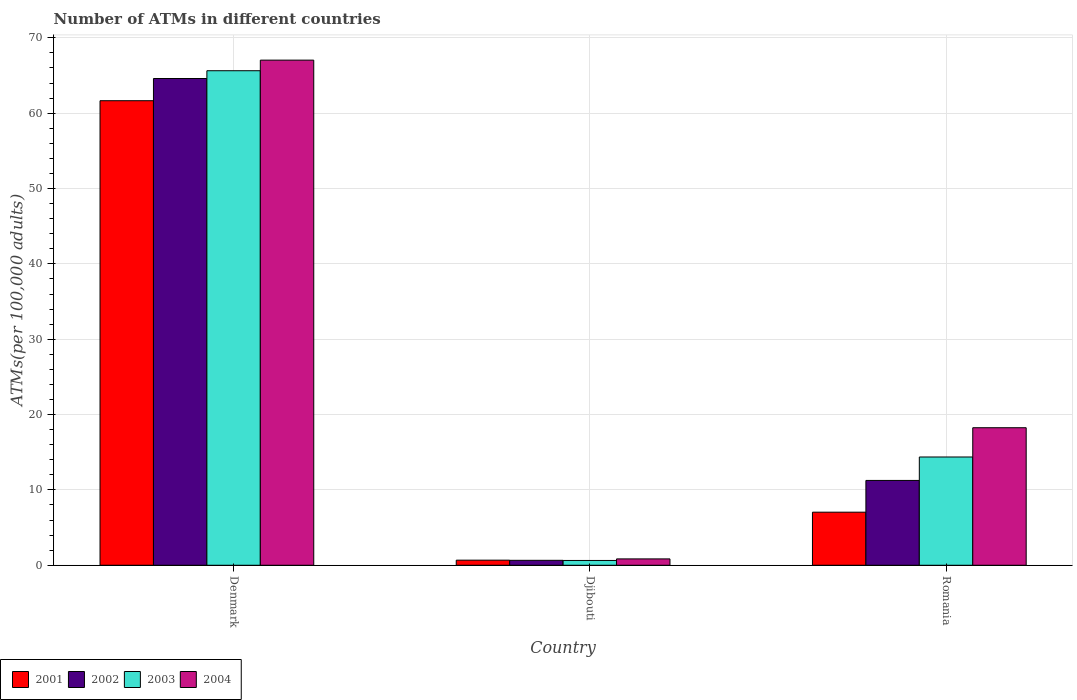How many different coloured bars are there?
Offer a very short reply. 4. How many bars are there on the 1st tick from the left?
Ensure brevity in your answer.  4. What is the label of the 3rd group of bars from the left?
Keep it short and to the point. Romania. In how many cases, is the number of bars for a given country not equal to the number of legend labels?
Provide a succinct answer. 0. What is the number of ATMs in 2004 in Djibouti?
Your response must be concise. 0.84. Across all countries, what is the maximum number of ATMs in 2002?
Keep it short and to the point. 64.61. Across all countries, what is the minimum number of ATMs in 2002?
Your answer should be compact. 0.66. In which country was the number of ATMs in 2001 minimum?
Your answer should be very brief. Djibouti. What is the total number of ATMs in 2003 in the graph?
Offer a terse response. 80.65. What is the difference between the number of ATMs in 2003 in Djibouti and that in Romania?
Offer a very short reply. -13.73. What is the difference between the number of ATMs in 2002 in Denmark and the number of ATMs in 2001 in Romania?
Make the answer very short. 57.56. What is the average number of ATMs in 2002 per country?
Your answer should be compact. 25.51. What is the difference between the number of ATMs of/in 2002 and number of ATMs of/in 2003 in Denmark?
Your answer should be compact. -1.03. What is the ratio of the number of ATMs in 2004 in Denmark to that in Djibouti?
Your response must be concise. 79.46. Is the number of ATMs in 2003 in Denmark less than that in Romania?
Give a very brief answer. No. Is the difference between the number of ATMs in 2002 in Djibouti and Romania greater than the difference between the number of ATMs in 2003 in Djibouti and Romania?
Offer a very short reply. Yes. What is the difference between the highest and the second highest number of ATMs in 2004?
Your answer should be very brief. -17.41. What is the difference between the highest and the lowest number of ATMs in 2004?
Keep it short and to the point. 66.2. Is the sum of the number of ATMs in 2002 in Denmark and Romania greater than the maximum number of ATMs in 2004 across all countries?
Keep it short and to the point. Yes. What does the 2nd bar from the left in Djibouti represents?
Ensure brevity in your answer.  2002. What does the 2nd bar from the right in Djibouti represents?
Your answer should be very brief. 2003. What is the difference between two consecutive major ticks on the Y-axis?
Give a very brief answer. 10. Are the values on the major ticks of Y-axis written in scientific E-notation?
Offer a very short reply. No. Does the graph contain any zero values?
Keep it short and to the point. No. Where does the legend appear in the graph?
Ensure brevity in your answer.  Bottom left. How many legend labels are there?
Provide a short and direct response. 4. What is the title of the graph?
Offer a terse response. Number of ATMs in different countries. What is the label or title of the Y-axis?
Offer a very short reply. ATMs(per 100,0 adults). What is the ATMs(per 100,000 adults) in 2001 in Denmark?
Provide a short and direct response. 61.66. What is the ATMs(per 100,000 adults) in 2002 in Denmark?
Give a very brief answer. 64.61. What is the ATMs(per 100,000 adults) in 2003 in Denmark?
Provide a succinct answer. 65.64. What is the ATMs(per 100,000 adults) in 2004 in Denmark?
Offer a very short reply. 67.04. What is the ATMs(per 100,000 adults) in 2001 in Djibouti?
Your response must be concise. 0.68. What is the ATMs(per 100,000 adults) in 2002 in Djibouti?
Offer a terse response. 0.66. What is the ATMs(per 100,000 adults) in 2003 in Djibouti?
Give a very brief answer. 0.64. What is the ATMs(per 100,000 adults) of 2004 in Djibouti?
Your answer should be compact. 0.84. What is the ATMs(per 100,000 adults) of 2001 in Romania?
Your answer should be very brief. 7.04. What is the ATMs(per 100,000 adults) of 2002 in Romania?
Your response must be concise. 11.26. What is the ATMs(per 100,000 adults) in 2003 in Romania?
Keep it short and to the point. 14.37. What is the ATMs(per 100,000 adults) in 2004 in Romania?
Ensure brevity in your answer.  18.26. Across all countries, what is the maximum ATMs(per 100,000 adults) in 2001?
Your answer should be very brief. 61.66. Across all countries, what is the maximum ATMs(per 100,000 adults) in 2002?
Ensure brevity in your answer.  64.61. Across all countries, what is the maximum ATMs(per 100,000 adults) of 2003?
Provide a short and direct response. 65.64. Across all countries, what is the maximum ATMs(per 100,000 adults) in 2004?
Your answer should be compact. 67.04. Across all countries, what is the minimum ATMs(per 100,000 adults) in 2001?
Offer a terse response. 0.68. Across all countries, what is the minimum ATMs(per 100,000 adults) of 2002?
Offer a terse response. 0.66. Across all countries, what is the minimum ATMs(per 100,000 adults) in 2003?
Ensure brevity in your answer.  0.64. Across all countries, what is the minimum ATMs(per 100,000 adults) of 2004?
Offer a very short reply. 0.84. What is the total ATMs(per 100,000 adults) in 2001 in the graph?
Make the answer very short. 69.38. What is the total ATMs(per 100,000 adults) in 2002 in the graph?
Ensure brevity in your answer.  76.52. What is the total ATMs(per 100,000 adults) in 2003 in the graph?
Your response must be concise. 80.65. What is the total ATMs(per 100,000 adults) of 2004 in the graph?
Keep it short and to the point. 86.14. What is the difference between the ATMs(per 100,000 adults) in 2001 in Denmark and that in Djibouti?
Offer a very short reply. 60.98. What is the difference between the ATMs(per 100,000 adults) of 2002 in Denmark and that in Djibouti?
Your response must be concise. 63.95. What is the difference between the ATMs(per 100,000 adults) in 2003 in Denmark and that in Djibouti?
Your response must be concise. 65. What is the difference between the ATMs(per 100,000 adults) in 2004 in Denmark and that in Djibouti?
Your response must be concise. 66.2. What is the difference between the ATMs(per 100,000 adults) of 2001 in Denmark and that in Romania?
Your answer should be compact. 54.61. What is the difference between the ATMs(per 100,000 adults) of 2002 in Denmark and that in Romania?
Keep it short and to the point. 53.35. What is the difference between the ATMs(per 100,000 adults) in 2003 in Denmark and that in Romania?
Ensure brevity in your answer.  51.27. What is the difference between the ATMs(per 100,000 adults) of 2004 in Denmark and that in Romania?
Your response must be concise. 48.79. What is the difference between the ATMs(per 100,000 adults) in 2001 in Djibouti and that in Romania?
Your answer should be compact. -6.37. What is the difference between the ATMs(per 100,000 adults) of 2002 in Djibouti and that in Romania?
Offer a terse response. -10.6. What is the difference between the ATMs(per 100,000 adults) in 2003 in Djibouti and that in Romania?
Offer a terse response. -13.73. What is the difference between the ATMs(per 100,000 adults) in 2004 in Djibouti and that in Romania?
Offer a very short reply. -17.41. What is the difference between the ATMs(per 100,000 adults) in 2001 in Denmark and the ATMs(per 100,000 adults) in 2002 in Djibouti?
Keep it short and to the point. 61. What is the difference between the ATMs(per 100,000 adults) of 2001 in Denmark and the ATMs(per 100,000 adults) of 2003 in Djibouti?
Offer a terse response. 61.02. What is the difference between the ATMs(per 100,000 adults) of 2001 in Denmark and the ATMs(per 100,000 adults) of 2004 in Djibouti?
Offer a terse response. 60.81. What is the difference between the ATMs(per 100,000 adults) of 2002 in Denmark and the ATMs(per 100,000 adults) of 2003 in Djibouti?
Ensure brevity in your answer.  63.97. What is the difference between the ATMs(per 100,000 adults) of 2002 in Denmark and the ATMs(per 100,000 adults) of 2004 in Djibouti?
Give a very brief answer. 63.76. What is the difference between the ATMs(per 100,000 adults) of 2003 in Denmark and the ATMs(per 100,000 adults) of 2004 in Djibouti?
Offer a very short reply. 64.79. What is the difference between the ATMs(per 100,000 adults) of 2001 in Denmark and the ATMs(per 100,000 adults) of 2002 in Romania?
Keep it short and to the point. 50.4. What is the difference between the ATMs(per 100,000 adults) of 2001 in Denmark and the ATMs(per 100,000 adults) of 2003 in Romania?
Your answer should be compact. 47.29. What is the difference between the ATMs(per 100,000 adults) in 2001 in Denmark and the ATMs(per 100,000 adults) in 2004 in Romania?
Offer a terse response. 43.4. What is the difference between the ATMs(per 100,000 adults) of 2002 in Denmark and the ATMs(per 100,000 adults) of 2003 in Romania?
Offer a terse response. 50.24. What is the difference between the ATMs(per 100,000 adults) of 2002 in Denmark and the ATMs(per 100,000 adults) of 2004 in Romania?
Give a very brief answer. 46.35. What is the difference between the ATMs(per 100,000 adults) of 2003 in Denmark and the ATMs(per 100,000 adults) of 2004 in Romania?
Keep it short and to the point. 47.38. What is the difference between the ATMs(per 100,000 adults) in 2001 in Djibouti and the ATMs(per 100,000 adults) in 2002 in Romania?
Offer a very short reply. -10.58. What is the difference between the ATMs(per 100,000 adults) in 2001 in Djibouti and the ATMs(per 100,000 adults) in 2003 in Romania?
Your answer should be compact. -13.69. What is the difference between the ATMs(per 100,000 adults) in 2001 in Djibouti and the ATMs(per 100,000 adults) in 2004 in Romania?
Make the answer very short. -17.58. What is the difference between the ATMs(per 100,000 adults) of 2002 in Djibouti and the ATMs(per 100,000 adults) of 2003 in Romania?
Your answer should be compact. -13.71. What is the difference between the ATMs(per 100,000 adults) of 2002 in Djibouti and the ATMs(per 100,000 adults) of 2004 in Romania?
Your answer should be compact. -17.6. What is the difference between the ATMs(per 100,000 adults) in 2003 in Djibouti and the ATMs(per 100,000 adults) in 2004 in Romania?
Your response must be concise. -17.62. What is the average ATMs(per 100,000 adults) of 2001 per country?
Offer a terse response. 23.13. What is the average ATMs(per 100,000 adults) in 2002 per country?
Give a very brief answer. 25.51. What is the average ATMs(per 100,000 adults) of 2003 per country?
Give a very brief answer. 26.88. What is the average ATMs(per 100,000 adults) of 2004 per country?
Offer a very short reply. 28.71. What is the difference between the ATMs(per 100,000 adults) of 2001 and ATMs(per 100,000 adults) of 2002 in Denmark?
Your answer should be very brief. -2.95. What is the difference between the ATMs(per 100,000 adults) of 2001 and ATMs(per 100,000 adults) of 2003 in Denmark?
Your response must be concise. -3.98. What is the difference between the ATMs(per 100,000 adults) of 2001 and ATMs(per 100,000 adults) of 2004 in Denmark?
Provide a short and direct response. -5.39. What is the difference between the ATMs(per 100,000 adults) of 2002 and ATMs(per 100,000 adults) of 2003 in Denmark?
Keep it short and to the point. -1.03. What is the difference between the ATMs(per 100,000 adults) of 2002 and ATMs(per 100,000 adults) of 2004 in Denmark?
Your answer should be compact. -2.44. What is the difference between the ATMs(per 100,000 adults) in 2003 and ATMs(per 100,000 adults) in 2004 in Denmark?
Ensure brevity in your answer.  -1.41. What is the difference between the ATMs(per 100,000 adults) of 2001 and ATMs(per 100,000 adults) of 2002 in Djibouti?
Provide a succinct answer. 0.02. What is the difference between the ATMs(per 100,000 adults) in 2001 and ATMs(per 100,000 adults) in 2003 in Djibouti?
Make the answer very short. 0.04. What is the difference between the ATMs(per 100,000 adults) of 2001 and ATMs(per 100,000 adults) of 2004 in Djibouti?
Give a very brief answer. -0.17. What is the difference between the ATMs(per 100,000 adults) in 2002 and ATMs(per 100,000 adults) in 2003 in Djibouti?
Offer a very short reply. 0.02. What is the difference between the ATMs(per 100,000 adults) of 2002 and ATMs(per 100,000 adults) of 2004 in Djibouti?
Your answer should be very brief. -0.19. What is the difference between the ATMs(per 100,000 adults) in 2003 and ATMs(per 100,000 adults) in 2004 in Djibouti?
Make the answer very short. -0.21. What is the difference between the ATMs(per 100,000 adults) of 2001 and ATMs(per 100,000 adults) of 2002 in Romania?
Your response must be concise. -4.21. What is the difference between the ATMs(per 100,000 adults) of 2001 and ATMs(per 100,000 adults) of 2003 in Romania?
Ensure brevity in your answer.  -7.32. What is the difference between the ATMs(per 100,000 adults) of 2001 and ATMs(per 100,000 adults) of 2004 in Romania?
Give a very brief answer. -11.21. What is the difference between the ATMs(per 100,000 adults) of 2002 and ATMs(per 100,000 adults) of 2003 in Romania?
Your answer should be very brief. -3.11. What is the difference between the ATMs(per 100,000 adults) in 2002 and ATMs(per 100,000 adults) in 2004 in Romania?
Offer a terse response. -7. What is the difference between the ATMs(per 100,000 adults) in 2003 and ATMs(per 100,000 adults) in 2004 in Romania?
Give a very brief answer. -3.89. What is the ratio of the ATMs(per 100,000 adults) of 2001 in Denmark to that in Djibouti?
Give a very brief answer. 91.18. What is the ratio of the ATMs(per 100,000 adults) of 2002 in Denmark to that in Djibouti?
Keep it short and to the point. 98.45. What is the ratio of the ATMs(per 100,000 adults) in 2003 in Denmark to that in Djibouti?
Give a very brief answer. 102.88. What is the ratio of the ATMs(per 100,000 adults) of 2004 in Denmark to that in Djibouti?
Make the answer very short. 79.46. What is the ratio of the ATMs(per 100,000 adults) in 2001 in Denmark to that in Romania?
Offer a terse response. 8.75. What is the ratio of the ATMs(per 100,000 adults) in 2002 in Denmark to that in Romania?
Ensure brevity in your answer.  5.74. What is the ratio of the ATMs(per 100,000 adults) in 2003 in Denmark to that in Romania?
Keep it short and to the point. 4.57. What is the ratio of the ATMs(per 100,000 adults) of 2004 in Denmark to that in Romania?
Give a very brief answer. 3.67. What is the ratio of the ATMs(per 100,000 adults) of 2001 in Djibouti to that in Romania?
Keep it short and to the point. 0.1. What is the ratio of the ATMs(per 100,000 adults) in 2002 in Djibouti to that in Romania?
Ensure brevity in your answer.  0.06. What is the ratio of the ATMs(per 100,000 adults) in 2003 in Djibouti to that in Romania?
Your answer should be compact. 0.04. What is the ratio of the ATMs(per 100,000 adults) in 2004 in Djibouti to that in Romania?
Offer a very short reply. 0.05. What is the difference between the highest and the second highest ATMs(per 100,000 adults) in 2001?
Ensure brevity in your answer.  54.61. What is the difference between the highest and the second highest ATMs(per 100,000 adults) of 2002?
Your response must be concise. 53.35. What is the difference between the highest and the second highest ATMs(per 100,000 adults) of 2003?
Provide a succinct answer. 51.27. What is the difference between the highest and the second highest ATMs(per 100,000 adults) in 2004?
Your response must be concise. 48.79. What is the difference between the highest and the lowest ATMs(per 100,000 adults) in 2001?
Your answer should be very brief. 60.98. What is the difference between the highest and the lowest ATMs(per 100,000 adults) of 2002?
Provide a succinct answer. 63.95. What is the difference between the highest and the lowest ATMs(per 100,000 adults) of 2003?
Your answer should be very brief. 65. What is the difference between the highest and the lowest ATMs(per 100,000 adults) in 2004?
Give a very brief answer. 66.2. 